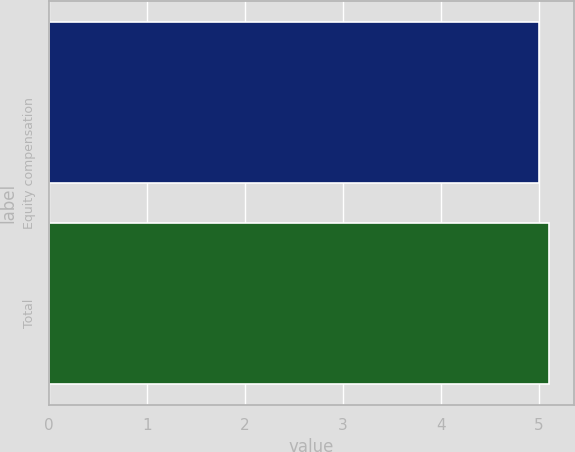Convert chart. <chart><loc_0><loc_0><loc_500><loc_500><bar_chart><fcel>Equity compensation<fcel>Total<nl><fcel>5<fcel>5.1<nl></chart> 